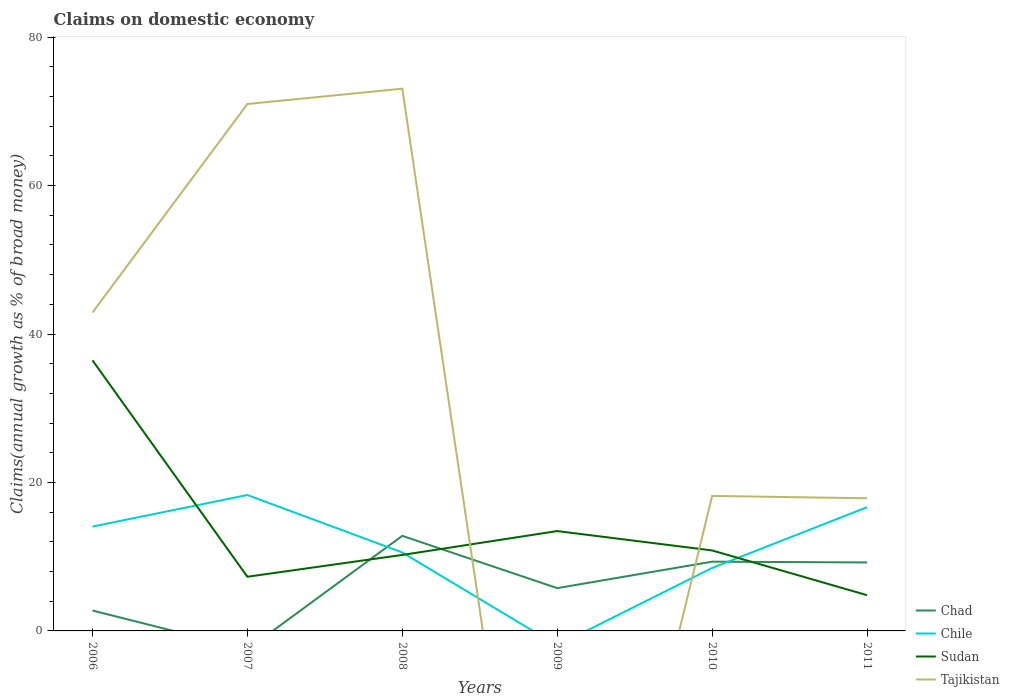Does the line corresponding to Chad intersect with the line corresponding to Tajikistan?
Provide a short and direct response. Yes. Is the number of lines equal to the number of legend labels?
Provide a succinct answer. No. Across all years, what is the maximum percentage of broad money claimed on domestic economy in Sudan?
Give a very brief answer. 4.82. What is the total percentage of broad money claimed on domestic economy in Chile in the graph?
Provide a succinct answer. 7.74. What is the difference between the highest and the second highest percentage of broad money claimed on domestic economy in Sudan?
Your answer should be compact. 31.65. What is the difference between the highest and the lowest percentage of broad money claimed on domestic economy in Tajikistan?
Offer a terse response. 3. Is the percentage of broad money claimed on domestic economy in Chad strictly greater than the percentage of broad money claimed on domestic economy in Tajikistan over the years?
Offer a very short reply. No. How many lines are there?
Give a very brief answer. 4. Are the values on the major ticks of Y-axis written in scientific E-notation?
Your answer should be compact. No. Does the graph contain any zero values?
Your response must be concise. Yes. Where does the legend appear in the graph?
Make the answer very short. Bottom right. What is the title of the graph?
Offer a very short reply. Claims on domestic economy. Does "Tonga" appear as one of the legend labels in the graph?
Offer a very short reply. No. What is the label or title of the Y-axis?
Offer a very short reply. Claims(annual growth as % of broad money). What is the Claims(annual growth as % of broad money) of Chad in 2006?
Your response must be concise. 2.75. What is the Claims(annual growth as % of broad money) of Chile in 2006?
Keep it short and to the point. 14.06. What is the Claims(annual growth as % of broad money) of Sudan in 2006?
Your answer should be very brief. 36.47. What is the Claims(annual growth as % of broad money) of Tajikistan in 2006?
Provide a short and direct response. 42.9. What is the Claims(annual growth as % of broad money) of Chile in 2007?
Make the answer very short. 18.31. What is the Claims(annual growth as % of broad money) in Sudan in 2007?
Your response must be concise. 7.3. What is the Claims(annual growth as % of broad money) of Tajikistan in 2007?
Give a very brief answer. 70.99. What is the Claims(annual growth as % of broad money) in Chad in 2008?
Your answer should be compact. 12.81. What is the Claims(annual growth as % of broad money) of Chile in 2008?
Provide a succinct answer. 10.57. What is the Claims(annual growth as % of broad money) of Sudan in 2008?
Ensure brevity in your answer.  10.24. What is the Claims(annual growth as % of broad money) of Tajikistan in 2008?
Provide a short and direct response. 73.05. What is the Claims(annual growth as % of broad money) of Chad in 2009?
Your response must be concise. 5.77. What is the Claims(annual growth as % of broad money) of Sudan in 2009?
Provide a short and direct response. 13.45. What is the Claims(annual growth as % of broad money) in Tajikistan in 2009?
Keep it short and to the point. 0. What is the Claims(annual growth as % of broad money) in Chad in 2010?
Offer a very short reply. 9.33. What is the Claims(annual growth as % of broad money) in Chile in 2010?
Offer a terse response. 8.48. What is the Claims(annual growth as % of broad money) in Sudan in 2010?
Your answer should be very brief. 10.84. What is the Claims(annual growth as % of broad money) in Tajikistan in 2010?
Provide a short and direct response. 18.19. What is the Claims(annual growth as % of broad money) of Chad in 2011?
Ensure brevity in your answer.  9.22. What is the Claims(annual growth as % of broad money) of Chile in 2011?
Your answer should be compact. 16.67. What is the Claims(annual growth as % of broad money) in Sudan in 2011?
Your answer should be very brief. 4.82. What is the Claims(annual growth as % of broad money) in Tajikistan in 2011?
Your answer should be very brief. 17.87. Across all years, what is the maximum Claims(annual growth as % of broad money) in Chad?
Keep it short and to the point. 12.81. Across all years, what is the maximum Claims(annual growth as % of broad money) of Chile?
Provide a succinct answer. 18.31. Across all years, what is the maximum Claims(annual growth as % of broad money) of Sudan?
Provide a short and direct response. 36.47. Across all years, what is the maximum Claims(annual growth as % of broad money) of Tajikistan?
Ensure brevity in your answer.  73.05. Across all years, what is the minimum Claims(annual growth as % of broad money) in Chad?
Offer a terse response. 0. Across all years, what is the minimum Claims(annual growth as % of broad money) in Chile?
Offer a terse response. 0. Across all years, what is the minimum Claims(annual growth as % of broad money) in Sudan?
Your answer should be very brief. 4.82. Across all years, what is the minimum Claims(annual growth as % of broad money) of Tajikistan?
Offer a terse response. 0. What is the total Claims(annual growth as % of broad money) of Chad in the graph?
Provide a short and direct response. 39.88. What is the total Claims(annual growth as % of broad money) of Chile in the graph?
Your answer should be very brief. 68.09. What is the total Claims(annual growth as % of broad money) in Sudan in the graph?
Offer a very short reply. 83.11. What is the total Claims(annual growth as % of broad money) in Tajikistan in the graph?
Your answer should be very brief. 223. What is the difference between the Claims(annual growth as % of broad money) of Chile in 2006 and that in 2007?
Provide a succinct answer. -4.25. What is the difference between the Claims(annual growth as % of broad money) in Sudan in 2006 and that in 2007?
Ensure brevity in your answer.  29.17. What is the difference between the Claims(annual growth as % of broad money) in Tajikistan in 2006 and that in 2007?
Give a very brief answer. -28.1. What is the difference between the Claims(annual growth as % of broad money) of Chad in 2006 and that in 2008?
Offer a very short reply. -10.06. What is the difference between the Claims(annual growth as % of broad money) in Chile in 2006 and that in 2008?
Make the answer very short. 3.49. What is the difference between the Claims(annual growth as % of broad money) of Sudan in 2006 and that in 2008?
Keep it short and to the point. 26.23. What is the difference between the Claims(annual growth as % of broad money) in Tajikistan in 2006 and that in 2008?
Your answer should be very brief. -30.16. What is the difference between the Claims(annual growth as % of broad money) in Chad in 2006 and that in 2009?
Your answer should be very brief. -3.02. What is the difference between the Claims(annual growth as % of broad money) in Sudan in 2006 and that in 2009?
Offer a terse response. 23.01. What is the difference between the Claims(annual growth as % of broad money) of Chad in 2006 and that in 2010?
Offer a terse response. -6.58. What is the difference between the Claims(annual growth as % of broad money) of Chile in 2006 and that in 2010?
Your answer should be very brief. 5.58. What is the difference between the Claims(annual growth as % of broad money) in Sudan in 2006 and that in 2010?
Your answer should be compact. 25.62. What is the difference between the Claims(annual growth as % of broad money) of Tajikistan in 2006 and that in 2010?
Offer a terse response. 24.71. What is the difference between the Claims(annual growth as % of broad money) in Chad in 2006 and that in 2011?
Your answer should be compact. -6.48. What is the difference between the Claims(annual growth as % of broad money) of Chile in 2006 and that in 2011?
Your answer should be very brief. -2.61. What is the difference between the Claims(annual growth as % of broad money) of Sudan in 2006 and that in 2011?
Your response must be concise. 31.65. What is the difference between the Claims(annual growth as % of broad money) of Tajikistan in 2006 and that in 2011?
Provide a short and direct response. 25.02. What is the difference between the Claims(annual growth as % of broad money) of Chile in 2007 and that in 2008?
Provide a succinct answer. 7.74. What is the difference between the Claims(annual growth as % of broad money) in Sudan in 2007 and that in 2008?
Offer a very short reply. -2.94. What is the difference between the Claims(annual growth as % of broad money) in Tajikistan in 2007 and that in 2008?
Provide a succinct answer. -2.06. What is the difference between the Claims(annual growth as % of broad money) in Sudan in 2007 and that in 2009?
Provide a short and direct response. -6.15. What is the difference between the Claims(annual growth as % of broad money) of Chile in 2007 and that in 2010?
Provide a succinct answer. 9.83. What is the difference between the Claims(annual growth as % of broad money) in Sudan in 2007 and that in 2010?
Make the answer very short. -3.54. What is the difference between the Claims(annual growth as % of broad money) of Tajikistan in 2007 and that in 2010?
Make the answer very short. 52.81. What is the difference between the Claims(annual growth as % of broad money) in Chile in 2007 and that in 2011?
Offer a very short reply. 1.65. What is the difference between the Claims(annual growth as % of broad money) in Sudan in 2007 and that in 2011?
Your answer should be very brief. 2.48. What is the difference between the Claims(annual growth as % of broad money) in Tajikistan in 2007 and that in 2011?
Your response must be concise. 53.12. What is the difference between the Claims(annual growth as % of broad money) in Chad in 2008 and that in 2009?
Offer a very short reply. 7.04. What is the difference between the Claims(annual growth as % of broad money) of Sudan in 2008 and that in 2009?
Ensure brevity in your answer.  -3.22. What is the difference between the Claims(annual growth as % of broad money) of Chad in 2008 and that in 2010?
Make the answer very short. 3.48. What is the difference between the Claims(annual growth as % of broad money) in Chile in 2008 and that in 2010?
Your response must be concise. 2.09. What is the difference between the Claims(annual growth as % of broad money) in Sudan in 2008 and that in 2010?
Provide a succinct answer. -0.6. What is the difference between the Claims(annual growth as % of broad money) in Tajikistan in 2008 and that in 2010?
Provide a succinct answer. 54.87. What is the difference between the Claims(annual growth as % of broad money) of Chad in 2008 and that in 2011?
Offer a very short reply. 3.59. What is the difference between the Claims(annual growth as % of broad money) of Chile in 2008 and that in 2011?
Give a very brief answer. -6.09. What is the difference between the Claims(annual growth as % of broad money) of Sudan in 2008 and that in 2011?
Make the answer very short. 5.42. What is the difference between the Claims(annual growth as % of broad money) in Tajikistan in 2008 and that in 2011?
Offer a terse response. 55.18. What is the difference between the Claims(annual growth as % of broad money) of Chad in 2009 and that in 2010?
Ensure brevity in your answer.  -3.56. What is the difference between the Claims(annual growth as % of broad money) of Sudan in 2009 and that in 2010?
Give a very brief answer. 2.61. What is the difference between the Claims(annual growth as % of broad money) of Chad in 2009 and that in 2011?
Ensure brevity in your answer.  -3.46. What is the difference between the Claims(annual growth as % of broad money) of Sudan in 2009 and that in 2011?
Give a very brief answer. 8.64. What is the difference between the Claims(annual growth as % of broad money) of Chad in 2010 and that in 2011?
Provide a short and direct response. 0.11. What is the difference between the Claims(annual growth as % of broad money) in Chile in 2010 and that in 2011?
Provide a succinct answer. -8.19. What is the difference between the Claims(annual growth as % of broad money) of Sudan in 2010 and that in 2011?
Give a very brief answer. 6.03. What is the difference between the Claims(annual growth as % of broad money) in Tajikistan in 2010 and that in 2011?
Ensure brevity in your answer.  0.32. What is the difference between the Claims(annual growth as % of broad money) of Chad in 2006 and the Claims(annual growth as % of broad money) of Chile in 2007?
Keep it short and to the point. -15.56. What is the difference between the Claims(annual growth as % of broad money) of Chad in 2006 and the Claims(annual growth as % of broad money) of Sudan in 2007?
Ensure brevity in your answer.  -4.55. What is the difference between the Claims(annual growth as % of broad money) in Chad in 2006 and the Claims(annual growth as % of broad money) in Tajikistan in 2007?
Your response must be concise. -68.25. What is the difference between the Claims(annual growth as % of broad money) of Chile in 2006 and the Claims(annual growth as % of broad money) of Sudan in 2007?
Your answer should be very brief. 6.76. What is the difference between the Claims(annual growth as % of broad money) in Chile in 2006 and the Claims(annual growth as % of broad money) in Tajikistan in 2007?
Offer a terse response. -56.94. What is the difference between the Claims(annual growth as % of broad money) of Sudan in 2006 and the Claims(annual growth as % of broad money) of Tajikistan in 2007?
Offer a very short reply. -34.53. What is the difference between the Claims(annual growth as % of broad money) in Chad in 2006 and the Claims(annual growth as % of broad money) in Chile in 2008?
Offer a terse response. -7.82. What is the difference between the Claims(annual growth as % of broad money) in Chad in 2006 and the Claims(annual growth as % of broad money) in Sudan in 2008?
Give a very brief answer. -7.49. What is the difference between the Claims(annual growth as % of broad money) of Chad in 2006 and the Claims(annual growth as % of broad money) of Tajikistan in 2008?
Ensure brevity in your answer.  -70.31. What is the difference between the Claims(annual growth as % of broad money) of Chile in 2006 and the Claims(annual growth as % of broad money) of Sudan in 2008?
Offer a terse response. 3.82. What is the difference between the Claims(annual growth as % of broad money) of Chile in 2006 and the Claims(annual growth as % of broad money) of Tajikistan in 2008?
Provide a succinct answer. -59. What is the difference between the Claims(annual growth as % of broad money) in Sudan in 2006 and the Claims(annual growth as % of broad money) in Tajikistan in 2008?
Ensure brevity in your answer.  -36.59. What is the difference between the Claims(annual growth as % of broad money) of Chad in 2006 and the Claims(annual growth as % of broad money) of Sudan in 2009?
Keep it short and to the point. -10.7. What is the difference between the Claims(annual growth as % of broad money) of Chile in 2006 and the Claims(annual growth as % of broad money) of Sudan in 2009?
Offer a very short reply. 0.6. What is the difference between the Claims(annual growth as % of broad money) of Chad in 2006 and the Claims(annual growth as % of broad money) of Chile in 2010?
Make the answer very short. -5.73. What is the difference between the Claims(annual growth as % of broad money) in Chad in 2006 and the Claims(annual growth as % of broad money) in Sudan in 2010?
Ensure brevity in your answer.  -8.09. What is the difference between the Claims(annual growth as % of broad money) in Chad in 2006 and the Claims(annual growth as % of broad money) in Tajikistan in 2010?
Make the answer very short. -15.44. What is the difference between the Claims(annual growth as % of broad money) of Chile in 2006 and the Claims(annual growth as % of broad money) of Sudan in 2010?
Make the answer very short. 3.22. What is the difference between the Claims(annual growth as % of broad money) of Chile in 2006 and the Claims(annual growth as % of broad money) of Tajikistan in 2010?
Keep it short and to the point. -4.13. What is the difference between the Claims(annual growth as % of broad money) of Sudan in 2006 and the Claims(annual growth as % of broad money) of Tajikistan in 2010?
Give a very brief answer. 18.28. What is the difference between the Claims(annual growth as % of broad money) in Chad in 2006 and the Claims(annual growth as % of broad money) in Chile in 2011?
Provide a succinct answer. -13.92. What is the difference between the Claims(annual growth as % of broad money) in Chad in 2006 and the Claims(annual growth as % of broad money) in Sudan in 2011?
Your answer should be very brief. -2.07. What is the difference between the Claims(annual growth as % of broad money) of Chad in 2006 and the Claims(annual growth as % of broad money) of Tajikistan in 2011?
Give a very brief answer. -15.12. What is the difference between the Claims(annual growth as % of broad money) of Chile in 2006 and the Claims(annual growth as % of broad money) of Sudan in 2011?
Make the answer very short. 9.24. What is the difference between the Claims(annual growth as % of broad money) in Chile in 2006 and the Claims(annual growth as % of broad money) in Tajikistan in 2011?
Your answer should be very brief. -3.81. What is the difference between the Claims(annual growth as % of broad money) in Sudan in 2006 and the Claims(annual growth as % of broad money) in Tajikistan in 2011?
Make the answer very short. 18.59. What is the difference between the Claims(annual growth as % of broad money) of Chile in 2007 and the Claims(annual growth as % of broad money) of Sudan in 2008?
Your answer should be very brief. 8.07. What is the difference between the Claims(annual growth as % of broad money) in Chile in 2007 and the Claims(annual growth as % of broad money) in Tajikistan in 2008?
Provide a short and direct response. -54.74. What is the difference between the Claims(annual growth as % of broad money) of Sudan in 2007 and the Claims(annual growth as % of broad money) of Tajikistan in 2008?
Offer a terse response. -65.76. What is the difference between the Claims(annual growth as % of broad money) of Chile in 2007 and the Claims(annual growth as % of broad money) of Sudan in 2009?
Give a very brief answer. 4.86. What is the difference between the Claims(annual growth as % of broad money) of Chile in 2007 and the Claims(annual growth as % of broad money) of Sudan in 2010?
Your response must be concise. 7.47. What is the difference between the Claims(annual growth as % of broad money) in Chile in 2007 and the Claims(annual growth as % of broad money) in Tajikistan in 2010?
Offer a very short reply. 0.12. What is the difference between the Claims(annual growth as % of broad money) in Sudan in 2007 and the Claims(annual growth as % of broad money) in Tajikistan in 2010?
Make the answer very short. -10.89. What is the difference between the Claims(annual growth as % of broad money) of Chile in 2007 and the Claims(annual growth as % of broad money) of Sudan in 2011?
Offer a very short reply. 13.5. What is the difference between the Claims(annual growth as % of broad money) of Chile in 2007 and the Claims(annual growth as % of broad money) of Tajikistan in 2011?
Your response must be concise. 0.44. What is the difference between the Claims(annual growth as % of broad money) in Sudan in 2007 and the Claims(annual growth as % of broad money) in Tajikistan in 2011?
Offer a very short reply. -10.57. What is the difference between the Claims(annual growth as % of broad money) in Chad in 2008 and the Claims(annual growth as % of broad money) in Sudan in 2009?
Provide a succinct answer. -0.64. What is the difference between the Claims(annual growth as % of broad money) of Chile in 2008 and the Claims(annual growth as % of broad money) of Sudan in 2009?
Make the answer very short. -2.88. What is the difference between the Claims(annual growth as % of broad money) of Chad in 2008 and the Claims(annual growth as % of broad money) of Chile in 2010?
Provide a succinct answer. 4.33. What is the difference between the Claims(annual growth as % of broad money) in Chad in 2008 and the Claims(annual growth as % of broad money) in Sudan in 2010?
Keep it short and to the point. 1.97. What is the difference between the Claims(annual growth as % of broad money) in Chad in 2008 and the Claims(annual growth as % of broad money) in Tajikistan in 2010?
Ensure brevity in your answer.  -5.38. What is the difference between the Claims(annual growth as % of broad money) of Chile in 2008 and the Claims(annual growth as % of broad money) of Sudan in 2010?
Your response must be concise. -0.27. What is the difference between the Claims(annual growth as % of broad money) of Chile in 2008 and the Claims(annual growth as % of broad money) of Tajikistan in 2010?
Offer a terse response. -7.62. What is the difference between the Claims(annual growth as % of broad money) of Sudan in 2008 and the Claims(annual growth as % of broad money) of Tajikistan in 2010?
Your answer should be very brief. -7.95. What is the difference between the Claims(annual growth as % of broad money) in Chad in 2008 and the Claims(annual growth as % of broad money) in Chile in 2011?
Your response must be concise. -3.86. What is the difference between the Claims(annual growth as % of broad money) of Chad in 2008 and the Claims(annual growth as % of broad money) of Sudan in 2011?
Make the answer very short. 7.99. What is the difference between the Claims(annual growth as % of broad money) in Chad in 2008 and the Claims(annual growth as % of broad money) in Tajikistan in 2011?
Provide a succinct answer. -5.06. What is the difference between the Claims(annual growth as % of broad money) in Chile in 2008 and the Claims(annual growth as % of broad money) in Sudan in 2011?
Give a very brief answer. 5.76. What is the difference between the Claims(annual growth as % of broad money) in Chile in 2008 and the Claims(annual growth as % of broad money) in Tajikistan in 2011?
Provide a succinct answer. -7.3. What is the difference between the Claims(annual growth as % of broad money) of Sudan in 2008 and the Claims(annual growth as % of broad money) of Tajikistan in 2011?
Ensure brevity in your answer.  -7.63. What is the difference between the Claims(annual growth as % of broad money) of Chad in 2009 and the Claims(annual growth as % of broad money) of Chile in 2010?
Give a very brief answer. -2.72. What is the difference between the Claims(annual growth as % of broad money) in Chad in 2009 and the Claims(annual growth as % of broad money) in Sudan in 2010?
Your response must be concise. -5.08. What is the difference between the Claims(annual growth as % of broad money) of Chad in 2009 and the Claims(annual growth as % of broad money) of Tajikistan in 2010?
Ensure brevity in your answer.  -12.42. What is the difference between the Claims(annual growth as % of broad money) of Sudan in 2009 and the Claims(annual growth as % of broad money) of Tajikistan in 2010?
Keep it short and to the point. -4.73. What is the difference between the Claims(annual growth as % of broad money) in Chad in 2009 and the Claims(annual growth as % of broad money) in Chile in 2011?
Make the answer very short. -10.9. What is the difference between the Claims(annual growth as % of broad money) in Chad in 2009 and the Claims(annual growth as % of broad money) in Sudan in 2011?
Keep it short and to the point. 0.95. What is the difference between the Claims(annual growth as % of broad money) of Chad in 2009 and the Claims(annual growth as % of broad money) of Tajikistan in 2011?
Your answer should be compact. -12.11. What is the difference between the Claims(annual growth as % of broad money) of Sudan in 2009 and the Claims(annual growth as % of broad money) of Tajikistan in 2011?
Provide a short and direct response. -4.42. What is the difference between the Claims(annual growth as % of broad money) in Chad in 2010 and the Claims(annual growth as % of broad money) in Chile in 2011?
Keep it short and to the point. -7.34. What is the difference between the Claims(annual growth as % of broad money) of Chad in 2010 and the Claims(annual growth as % of broad money) of Sudan in 2011?
Provide a succinct answer. 4.51. What is the difference between the Claims(annual growth as % of broad money) in Chad in 2010 and the Claims(annual growth as % of broad money) in Tajikistan in 2011?
Offer a terse response. -8.54. What is the difference between the Claims(annual growth as % of broad money) of Chile in 2010 and the Claims(annual growth as % of broad money) of Sudan in 2011?
Keep it short and to the point. 3.67. What is the difference between the Claims(annual growth as % of broad money) of Chile in 2010 and the Claims(annual growth as % of broad money) of Tajikistan in 2011?
Your answer should be compact. -9.39. What is the difference between the Claims(annual growth as % of broad money) in Sudan in 2010 and the Claims(annual growth as % of broad money) in Tajikistan in 2011?
Offer a terse response. -7.03. What is the average Claims(annual growth as % of broad money) of Chad per year?
Your answer should be compact. 6.65. What is the average Claims(annual growth as % of broad money) in Chile per year?
Keep it short and to the point. 11.35. What is the average Claims(annual growth as % of broad money) in Sudan per year?
Offer a very short reply. 13.85. What is the average Claims(annual growth as % of broad money) in Tajikistan per year?
Offer a terse response. 37.17. In the year 2006, what is the difference between the Claims(annual growth as % of broad money) of Chad and Claims(annual growth as % of broad money) of Chile?
Provide a short and direct response. -11.31. In the year 2006, what is the difference between the Claims(annual growth as % of broad money) of Chad and Claims(annual growth as % of broad money) of Sudan?
Offer a very short reply. -33.72. In the year 2006, what is the difference between the Claims(annual growth as % of broad money) of Chad and Claims(annual growth as % of broad money) of Tajikistan?
Make the answer very short. -40.15. In the year 2006, what is the difference between the Claims(annual growth as % of broad money) of Chile and Claims(annual growth as % of broad money) of Sudan?
Give a very brief answer. -22.41. In the year 2006, what is the difference between the Claims(annual growth as % of broad money) in Chile and Claims(annual growth as % of broad money) in Tajikistan?
Offer a terse response. -28.84. In the year 2006, what is the difference between the Claims(annual growth as % of broad money) of Sudan and Claims(annual growth as % of broad money) of Tajikistan?
Make the answer very short. -6.43. In the year 2007, what is the difference between the Claims(annual growth as % of broad money) of Chile and Claims(annual growth as % of broad money) of Sudan?
Offer a terse response. 11.01. In the year 2007, what is the difference between the Claims(annual growth as % of broad money) in Chile and Claims(annual growth as % of broad money) in Tajikistan?
Your response must be concise. -52.68. In the year 2007, what is the difference between the Claims(annual growth as % of broad money) of Sudan and Claims(annual growth as % of broad money) of Tajikistan?
Your response must be concise. -63.69. In the year 2008, what is the difference between the Claims(annual growth as % of broad money) of Chad and Claims(annual growth as % of broad money) of Chile?
Offer a terse response. 2.24. In the year 2008, what is the difference between the Claims(annual growth as % of broad money) of Chad and Claims(annual growth as % of broad money) of Sudan?
Make the answer very short. 2.57. In the year 2008, what is the difference between the Claims(annual growth as % of broad money) in Chad and Claims(annual growth as % of broad money) in Tajikistan?
Keep it short and to the point. -60.25. In the year 2008, what is the difference between the Claims(annual growth as % of broad money) of Chile and Claims(annual growth as % of broad money) of Sudan?
Your answer should be very brief. 0.33. In the year 2008, what is the difference between the Claims(annual growth as % of broad money) in Chile and Claims(annual growth as % of broad money) in Tajikistan?
Ensure brevity in your answer.  -62.48. In the year 2008, what is the difference between the Claims(annual growth as % of broad money) of Sudan and Claims(annual growth as % of broad money) of Tajikistan?
Keep it short and to the point. -62.82. In the year 2009, what is the difference between the Claims(annual growth as % of broad money) in Chad and Claims(annual growth as % of broad money) in Sudan?
Your answer should be very brief. -7.69. In the year 2010, what is the difference between the Claims(annual growth as % of broad money) in Chad and Claims(annual growth as % of broad money) in Chile?
Provide a short and direct response. 0.85. In the year 2010, what is the difference between the Claims(annual growth as % of broad money) of Chad and Claims(annual growth as % of broad money) of Sudan?
Provide a short and direct response. -1.51. In the year 2010, what is the difference between the Claims(annual growth as % of broad money) of Chad and Claims(annual growth as % of broad money) of Tajikistan?
Make the answer very short. -8.86. In the year 2010, what is the difference between the Claims(annual growth as % of broad money) in Chile and Claims(annual growth as % of broad money) in Sudan?
Your answer should be very brief. -2.36. In the year 2010, what is the difference between the Claims(annual growth as % of broad money) of Chile and Claims(annual growth as % of broad money) of Tajikistan?
Make the answer very short. -9.71. In the year 2010, what is the difference between the Claims(annual growth as % of broad money) of Sudan and Claims(annual growth as % of broad money) of Tajikistan?
Give a very brief answer. -7.35. In the year 2011, what is the difference between the Claims(annual growth as % of broad money) in Chad and Claims(annual growth as % of broad money) in Chile?
Keep it short and to the point. -7.44. In the year 2011, what is the difference between the Claims(annual growth as % of broad money) in Chad and Claims(annual growth as % of broad money) in Sudan?
Provide a short and direct response. 4.41. In the year 2011, what is the difference between the Claims(annual growth as % of broad money) of Chad and Claims(annual growth as % of broad money) of Tajikistan?
Your answer should be compact. -8.65. In the year 2011, what is the difference between the Claims(annual growth as % of broad money) of Chile and Claims(annual growth as % of broad money) of Sudan?
Provide a short and direct response. 11.85. In the year 2011, what is the difference between the Claims(annual growth as % of broad money) in Chile and Claims(annual growth as % of broad money) in Tajikistan?
Offer a very short reply. -1.2. In the year 2011, what is the difference between the Claims(annual growth as % of broad money) in Sudan and Claims(annual growth as % of broad money) in Tajikistan?
Your answer should be compact. -13.06. What is the ratio of the Claims(annual growth as % of broad money) in Chile in 2006 to that in 2007?
Make the answer very short. 0.77. What is the ratio of the Claims(annual growth as % of broad money) in Sudan in 2006 to that in 2007?
Offer a terse response. 5. What is the ratio of the Claims(annual growth as % of broad money) in Tajikistan in 2006 to that in 2007?
Offer a terse response. 0.6. What is the ratio of the Claims(annual growth as % of broad money) of Chad in 2006 to that in 2008?
Ensure brevity in your answer.  0.21. What is the ratio of the Claims(annual growth as % of broad money) of Chile in 2006 to that in 2008?
Offer a very short reply. 1.33. What is the ratio of the Claims(annual growth as % of broad money) in Sudan in 2006 to that in 2008?
Make the answer very short. 3.56. What is the ratio of the Claims(annual growth as % of broad money) of Tajikistan in 2006 to that in 2008?
Make the answer very short. 0.59. What is the ratio of the Claims(annual growth as % of broad money) in Chad in 2006 to that in 2009?
Your answer should be compact. 0.48. What is the ratio of the Claims(annual growth as % of broad money) of Sudan in 2006 to that in 2009?
Give a very brief answer. 2.71. What is the ratio of the Claims(annual growth as % of broad money) of Chad in 2006 to that in 2010?
Give a very brief answer. 0.29. What is the ratio of the Claims(annual growth as % of broad money) of Chile in 2006 to that in 2010?
Make the answer very short. 1.66. What is the ratio of the Claims(annual growth as % of broad money) of Sudan in 2006 to that in 2010?
Ensure brevity in your answer.  3.36. What is the ratio of the Claims(annual growth as % of broad money) in Tajikistan in 2006 to that in 2010?
Keep it short and to the point. 2.36. What is the ratio of the Claims(annual growth as % of broad money) of Chad in 2006 to that in 2011?
Make the answer very short. 0.3. What is the ratio of the Claims(annual growth as % of broad money) of Chile in 2006 to that in 2011?
Your answer should be very brief. 0.84. What is the ratio of the Claims(annual growth as % of broad money) in Sudan in 2006 to that in 2011?
Provide a succinct answer. 7.57. What is the ratio of the Claims(annual growth as % of broad money) in Tajikistan in 2006 to that in 2011?
Ensure brevity in your answer.  2.4. What is the ratio of the Claims(annual growth as % of broad money) of Chile in 2007 to that in 2008?
Ensure brevity in your answer.  1.73. What is the ratio of the Claims(annual growth as % of broad money) in Sudan in 2007 to that in 2008?
Give a very brief answer. 0.71. What is the ratio of the Claims(annual growth as % of broad money) in Tajikistan in 2007 to that in 2008?
Make the answer very short. 0.97. What is the ratio of the Claims(annual growth as % of broad money) in Sudan in 2007 to that in 2009?
Make the answer very short. 0.54. What is the ratio of the Claims(annual growth as % of broad money) in Chile in 2007 to that in 2010?
Your answer should be compact. 2.16. What is the ratio of the Claims(annual growth as % of broad money) of Sudan in 2007 to that in 2010?
Ensure brevity in your answer.  0.67. What is the ratio of the Claims(annual growth as % of broad money) of Tajikistan in 2007 to that in 2010?
Offer a terse response. 3.9. What is the ratio of the Claims(annual growth as % of broad money) of Chile in 2007 to that in 2011?
Offer a terse response. 1.1. What is the ratio of the Claims(annual growth as % of broad money) of Sudan in 2007 to that in 2011?
Ensure brevity in your answer.  1.52. What is the ratio of the Claims(annual growth as % of broad money) in Tajikistan in 2007 to that in 2011?
Provide a short and direct response. 3.97. What is the ratio of the Claims(annual growth as % of broad money) in Chad in 2008 to that in 2009?
Make the answer very short. 2.22. What is the ratio of the Claims(annual growth as % of broad money) of Sudan in 2008 to that in 2009?
Ensure brevity in your answer.  0.76. What is the ratio of the Claims(annual growth as % of broad money) of Chad in 2008 to that in 2010?
Your answer should be very brief. 1.37. What is the ratio of the Claims(annual growth as % of broad money) of Chile in 2008 to that in 2010?
Your response must be concise. 1.25. What is the ratio of the Claims(annual growth as % of broad money) in Sudan in 2008 to that in 2010?
Your answer should be compact. 0.94. What is the ratio of the Claims(annual growth as % of broad money) of Tajikistan in 2008 to that in 2010?
Your response must be concise. 4.02. What is the ratio of the Claims(annual growth as % of broad money) in Chad in 2008 to that in 2011?
Keep it short and to the point. 1.39. What is the ratio of the Claims(annual growth as % of broad money) of Chile in 2008 to that in 2011?
Your answer should be compact. 0.63. What is the ratio of the Claims(annual growth as % of broad money) in Sudan in 2008 to that in 2011?
Keep it short and to the point. 2.13. What is the ratio of the Claims(annual growth as % of broad money) in Tajikistan in 2008 to that in 2011?
Provide a succinct answer. 4.09. What is the ratio of the Claims(annual growth as % of broad money) of Chad in 2009 to that in 2010?
Provide a succinct answer. 0.62. What is the ratio of the Claims(annual growth as % of broad money) in Sudan in 2009 to that in 2010?
Provide a short and direct response. 1.24. What is the ratio of the Claims(annual growth as % of broad money) of Chad in 2009 to that in 2011?
Your response must be concise. 0.63. What is the ratio of the Claims(annual growth as % of broad money) of Sudan in 2009 to that in 2011?
Provide a succinct answer. 2.79. What is the ratio of the Claims(annual growth as % of broad money) of Chad in 2010 to that in 2011?
Provide a succinct answer. 1.01. What is the ratio of the Claims(annual growth as % of broad money) of Chile in 2010 to that in 2011?
Make the answer very short. 0.51. What is the ratio of the Claims(annual growth as % of broad money) in Sudan in 2010 to that in 2011?
Keep it short and to the point. 2.25. What is the ratio of the Claims(annual growth as % of broad money) of Tajikistan in 2010 to that in 2011?
Provide a succinct answer. 1.02. What is the difference between the highest and the second highest Claims(annual growth as % of broad money) in Chad?
Make the answer very short. 3.48. What is the difference between the highest and the second highest Claims(annual growth as % of broad money) in Chile?
Provide a short and direct response. 1.65. What is the difference between the highest and the second highest Claims(annual growth as % of broad money) of Sudan?
Make the answer very short. 23.01. What is the difference between the highest and the second highest Claims(annual growth as % of broad money) of Tajikistan?
Keep it short and to the point. 2.06. What is the difference between the highest and the lowest Claims(annual growth as % of broad money) of Chad?
Provide a short and direct response. 12.81. What is the difference between the highest and the lowest Claims(annual growth as % of broad money) in Chile?
Offer a very short reply. 18.31. What is the difference between the highest and the lowest Claims(annual growth as % of broad money) in Sudan?
Provide a succinct answer. 31.65. What is the difference between the highest and the lowest Claims(annual growth as % of broad money) of Tajikistan?
Provide a succinct answer. 73.05. 